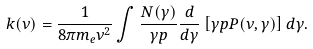<formula> <loc_0><loc_0><loc_500><loc_500>k ( \nu ) = \frac { 1 } { 8 \pi m _ { e } \nu ^ { 2 } } \int \frac { N ( \gamma ) } { \gamma p } \frac { d } { d \gamma } \left [ \gamma p P ( \nu , \gamma ) \right ] d \gamma .</formula> 